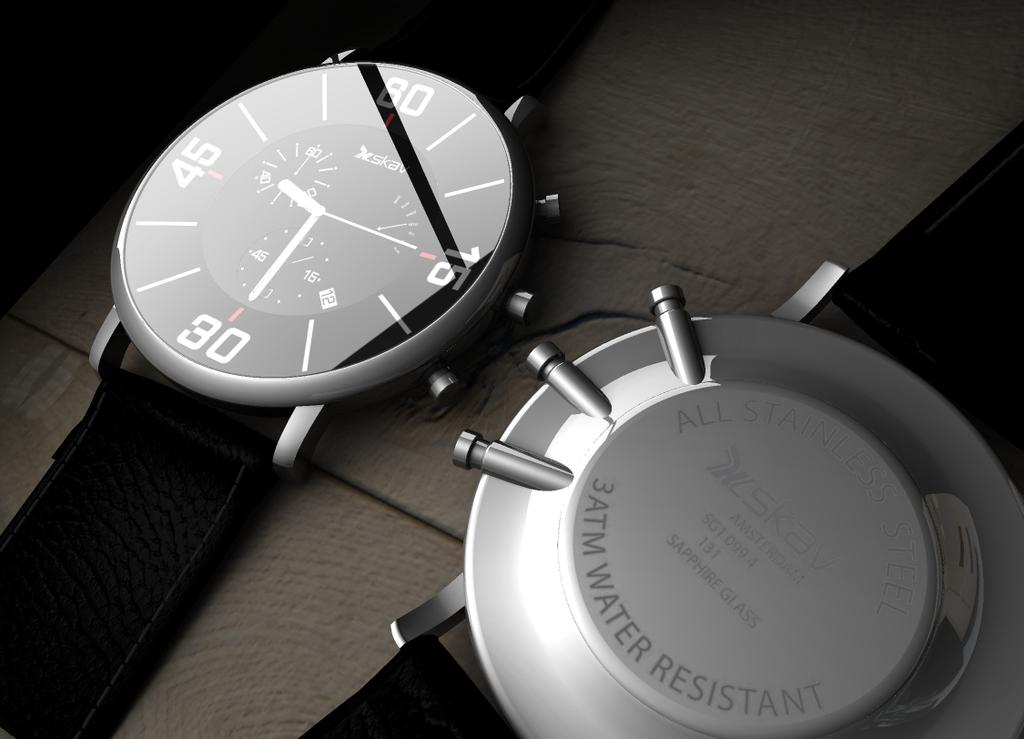<image>
Describe the image concisely. A up close shot of watches made by SKAV. 